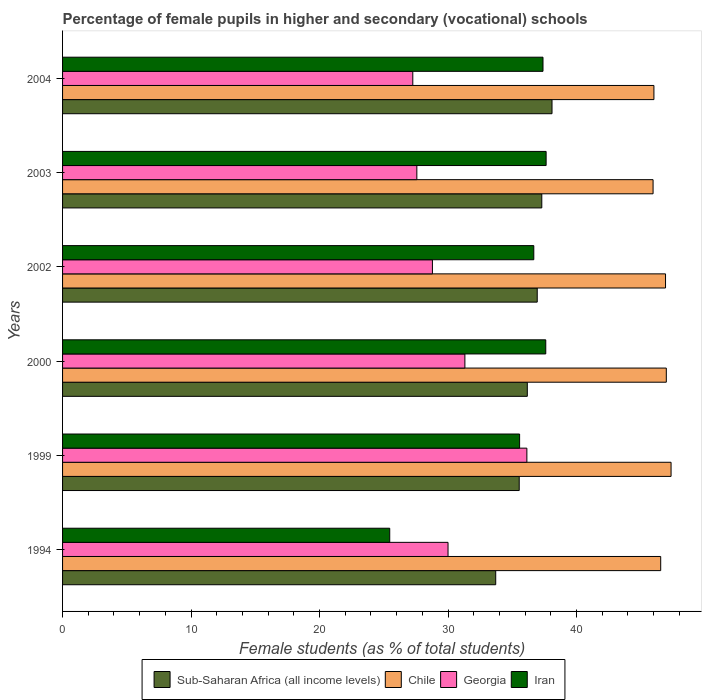How many different coloured bars are there?
Keep it short and to the point. 4. How many groups of bars are there?
Make the answer very short. 6. Are the number of bars on each tick of the Y-axis equal?
Your answer should be very brief. Yes. How many bars are there on the 4th tick from the bottom?
Your response must be concise. 4. What is the label of the 3rd group of bars from the top?
Keep it short and to the point. 2002. What is the percentage of female pupils in higher and secondary schools in Chile in 2000?
Ensure brevity in your answer.  46.99. Across all years, what is the maximum percentage of female pupils in higher and secondary schools in Iran?
Offer a terse response. 37.64. Across all years, what is the minimum percentage of female pupils in higher and secondary schools in Iran?
Keep it short and to the point. 25.46. In which year was the percentage of female pupils in higher and secondary schools in Sub-Saharan Africa (all income levels) maximum?
Give a very brief answer. 2004. In which year was the percentage of female pupils in higher and secondary schools in Iran minimum?
Ensure brevity in your answer.  1994. What is the total percentage of female pupils in higher and secondary schools in Georgia in the graph?
Your answer should be very brief. 181.07. What is the difference between the percentage of female pupils in higher and secondary schools in Georgia in 1999 and that in 2003?
Your answer should be very brief. 8.56. What is the difference between the percentage of female pupils in higher and secondary schools in Georgia in 2003 and the percentage of female pupils in higher and secondary schools in Chile in 2002?
Make the answer very short. -19.36. What is the average percentage of female pupils in higher and secondary schools in Chile per year?
Provide a short and direct response. 46.64. In the year 2004, what is the difference between the percentage of female pupils in higher and secondary schools in Georgia and percentage of female pupils in higher and secondary schools in Chile?
Your answer should be very brief. -18.77. In how many years, is the percentage of female pupils in higher and secondary schools in Georgia greater than 4 %?
Provide a short and direct response. 6. What is the ratio of the percentage of female pupils in higher and secondary schools in Iran in 2002 to that in 2004?
Offer a very short reply. 0.98. What is the difference between the highest and the second highest percentage of female pupils in higher and secondary schools in Sub-Saharan Africa (all income levels)?
Provide a short and direct response. 0.8. What is the difference between the highest and the lowest percentage of female pupils in higher and secondary schools in Sub-Saharan Africa (all income levels)?
Make the answer very short. 4.38. Is the sum of the percentage of female pupils in higher and secondary schools in Sub-Saharan Africa (all income levels) in 2002 and 2003 greater than the maximum percentage of female pupils in higher and secondary schools in Iran across all years?
Provide a short and direct response. Yes. What does the 4th bar from the bottom in 2003 represents?
Offer a very short reply. Iran. Is it the case that in every year, the sum of the percentage of female pupils in higher and secondary schools in Sub-Saharan Africa (all income levels) and percentage of female pupils in higher and secondary schools in Iran is greater than the percentage of female pupils in higher and secondary schools in Georgia?
Give a very brief answer. Yes. How are the legend labels stacked?
Give a very brief answer. Horizontal. What is the title of the graph?
Your answer should be compact. Percentage of female pupils in higher and secondary (vocational) schools. What is the label or title of the X-axis?
Keep it short and to the point. Female students (as % of total students). What is the label or title of the Y-axis?
Offer a very short reply. Years. What is the Female students (as % of total students) in Sub-Saharan Africa (all income levels) in 1994?
Provide a succinct answer. 33.71. What is the Female students (as % of total students) of Chile in 1994?
Ensure brevity in your answer.  46.55. What is the Female students (as % of total students) of Georgia in 1994?
Offer a terse response. 30. What is the Female students (as % of total students) in Iran in 1994?
Keep it short and to the point. 25.46. What is the Female students (as % of total students) in Sub-Saharan Africa (all income levels) in 1999?
Your answer should be compact. 35.54. What is the Female students (as % of total students) of Chile in 1999?
Your response must be concise. 47.36. What is the Female students (as % of total students) in Georgia in 1999?
Ensure brevity in your answer.  36.14. What is the Female students (as % of total students) of Iran in 1999?
Offer a very short reply. 35.57. What is the Female students (as % of total students) of Sub-Saharan Africa (all income levels) in 2000?
Your response must be concise. 36.17. What is the Female students (as % of total students) of Chile in 2000?
Your response must be concise. 46.99. What is the Female students (as % of total students) in Georgia in 2000?
Give a very brief answer. 31.31. What is the Female students (as % of total students) in Iran in 2000?
Ensure brevity in your answer.  37.61. What is the Female students (as % of total students) of Sub-Saharan Africa (all income levels) in 2002?
Your answer should be very brief. 36.94. What is the Female students (as % of total students) of Chile in 2002?
Keep it short and to the point. 46.93. What is the Female students (as % of total students) of Georgia in 2002?
Make the answer very short. 28.79. What is the Female students (as % of total students) in Iran in 2002?
Provide a short and direct response. 36.68. What is the Female students (as % of total students) of Sub-Saharan Africa (all income levels) in 2003?
Provide a short and direct response. 37.3. What is the Female students (as % of total students) in Chile in 2003?
Provide a short and direct response. 45.96. What is the Female students (as % of total students) in Georgia in 2003?
Provide a succinct answer. 27.57. What is the Female students (as % of total students) in Iran in 2003?
Provide a short and direct response. 37.64. What is the Female students (as % of total students) of Sub-Saharan Africa (all income levels) in 2004?
Provide a succinct answer. 38.1. What is the Female students (as % of total students) of Chile in 2004?
Your answer should be very brief. 46.03. What is the Female students (as % of total students) of Georgia in 2004?
Keep it short and to the point. 27.26. What is the Female students (as % of total students) of Iran in 2004?
Give a very brief answer. 37.39. Across all years, what is the maximum Female students (as % of total students) of Sub-Saharan Africa (all income levels)?
Provide a succinct answer. 38.1. Across all years, what is the maximum Female students (as % of total students) of Chile?
Your response must be concise. 47.36. Across all years, what is the maximum Female students (as % of total students) of Georgia?
Your answer should be compact. 36.14. Across all years, what is the maximum Female students (as % of total students) in Iran?
Make the answer very short. 37.64. Across all years, what is the minimum Female students (as % of total students) in Sub-Saharan Africa (all income levels)?
Ensure brevity in your answer.  33.71. Across all years, what is the minimum Female students (as % of total students) in Chile?
Provide a succinct answer. 45.96. Across all years, what is the minimum Female students (as % of total students) of Georgia?
Make the answer very short. 27.26. Across all years, what is the minimum Female students (as % of total students) of Iran?
Your response must be concise. 25.46. What is the total Female students (as % of total students) in Sub-Saharan Africa (all income levels) in the graph?
Provide a succinct answer. 217.77. What is the total Female students (as % of total students) in Chile in the graph?
Your answer should be compact. 279.82. What is the total Female students (as % of total students) in Georgia in the graph?
Your answer should be very brief. 181.07. What is the total Female students (as % of total students) of Iran in the graph?
Your answer should be very brief. 210.35. What is the difference between the Female students (as % of total students) of Sub-Saharan Africa (all income levels) in 1994 and that in 1999?
Keep it short and to the point. -1.83. What is the difference between the Female students (as % of total students) in Chile in 1994 and that in 1999?
Your response must be concise. -0.81. What is the difference between the Female students (as % of total students) in Georgia in 1994 and that in 1999?
Provide a short and direct response. -6.14. What is the difference between the Female students (as % of total students) of Iran in 1994 and that in 1999?
Ensure brevity in your answer.  -10.11. What is the difference between the Female students (as % of total students) of Sub-Saharan Africa (all income levels) in 1994 and that in 2000?
Your answer should be very brief. -2.46. What is the difference between the Female students (as % of total students) of Chile in 1994 and that in 2000?
Your answer should be very brief. -0.44. What is the difference between the Female students (as % of total students) of Georgia in 1994 and that in 2000?
Your response must be concise. -1.31. What is the difference between the Female students (as % of total students) in Iran in 1994 and that in 2000?
Offer a terse response. -12.15. What is the difference between the Female students (as % of total students) of Sub-Saharan Africa (all income levels) in 1994 and that in 2002?
Keep it short and to the point. -3.23. What is the difference between the Female students (as % of total students) of Chile in 1994 and that in 2002?
Provide a succinct answer. -0.38. What is the difference between the Female students (as % of total students) in Georgia in 1994 and that in 2002?
Provide a short and direct response. 1.22. What is the difference between the Female students (as % of total students) of Iran in 1994 and that in 2002?
Your answer should be compact. -11.21. What is the difference between the Female students (as % of total students) in Sub-Saharan Africa (all income levels) in 1994 and that in 2003?
Give a very brief answer. -3.59. What is the difference between the Female students (as % of total students) of Chile in 1994 and that in 2003?
Offer a terse response. 0.59. What is the difference between the Female students (as % of total students) of Georgia in 1994 and that in 2003?
Your answer should be compact. 2.43. What is the difference between the Female students (as % of total students) of Iran in 1994 and that in 2003?
Make the answer very short. -12.17. What is the difference between the Female students (as % of total students) of Sub-Saharan Africa (all income levels) in 1994 and that in 2004?
Make the answer very short. -4.38. What is the difference between the Female students (as % of total students) of Chile in 1994 and that in 2004?
Provide a succinct answer. 0.53. What is the difference between the Female students (as % of total students) of Georgia in 1994 and that in 2004?
Offer a terse response. 2.74. What is the difference between the Female students (as % of total students) of Iran in 1994 and that in 2004?
Offer a very short reply. -11.93. What is the difference between the Female students (as % of total students) of Sub-Saharan Africa (all income levels) in 1999 and that in 2000?
Offer a terse response. -0.63. What is the difference between the Female students (as % of total students) of Chile in 1999 and that in 2000?
Offer a terse response. 0.37. What is the difference between the Female students (as % of total students) in Georgia in 1999 and that in 2000?
Provide a short and direct response. 4.82. What is the difference between the Female students (as % of total students) of Iran in 1999 and that in 2000?
Offer a terse response. -2.04. What is the difference between the Female students (as % of total students) in Sub-Saharan Africa (all income levels) in 1999 and that in 2002?
Provide a short and direct response. -1.4. What is the difference between the Female students (as % of total students) in Chile in 1999 and that in 2002?
Give a very brief answer. 0.43. What is the difference between the Female students (as % of total students) of Georgia in 1999 and that in 2002?
Provide a short and direct response. 7.35. What is the difference between the Female students (as % of total students) of Iran in 1999 and that in 2002?
Give a very brief answer. -1.1. What is the difference between the Female students (as % of total students) in Sub-Saharan Africa (all income levels) in 1999 and that in 2003?
Make the answer very short. -1.76. What is the difference between the Female students (as % of total students) of Chile in 1999 and that in 2003?
Ensure brevity in your answer.  1.4. What is the difference between the Female students (as % of total students) in Georgia in 1999 and that in 2003?
Give a very brief answer. 8.56. What is the difference between the Female students (as % of total students) of Iran in 1999 and that in 2003?
Provide a succinct answer. -2.06. What is the difference between the Female students (as % of total students) of Sub-Saharan Africa (all income levels) in 1999 and that in 2004?
Make the answer very short. -2.55. What is the difference between the Female students (as % of total students) of Chile in 1999 and that in 2004?
Provide a short and direct response. 1.33. What is the difference between the Female students (as % of total students) of Georgia in 1999 and that in 2004?
Keep it short and to the point. 8.88. What is the difference between the Female students (as % of total students) in Iran in 1999 and that in 2004?
Offer a very short reply. -1.82. What is the difference between the Female students (as % of total students) in Sub-Saharan Africa (all income levels) in 2000 and that in 2002?
Ensure brevity in your answer.  -0.77. What is the difference between the Female students (as % of total students) of Chile in 2000 and that in 2002?
Your answer should be compact. 0.06. What is the difference between the Female students (as % of total students) of Georgia in 2000 and that in 2002?
Ensure brevity in your answer.  2.53. What is the difference between the Female students (as % of total students) of Iran in 2000 and that in 2002?
Keep it short and to the point. 0.93. What is the difference between the Female students (as % of total students) of Sub-Saharan Africa (all income levels) in 2000 and that in 2003?
Your answer should be compact. -1.13. What is the difference between the Female students (as % of total students) in Chile in 2000 and that in 2003?
Your response must be concise. 1.03. What is the difference between the Female students (as % of total students) in Georgia in 2000 and that in 2003?
Offer a terse response. 3.74. What is the difference between the Female students (as % of total students) of Iran in 2000 and that in 2003?
Your response must be concise. -0.03. What is the difference between the Female students (as % of total students) in Sub-Saharan Africa (all income levels) in 2000 and that in 2004?
Give a very brief answer. -1.92. What is the difference between the Female students (as % of total students) in Chile in 2000 and that in 2004?
Your answer should be compact. 0.96. What is the difference between the Female students (as % of total students) of Georgia in 2000 and that in 2004?
Give a very brief answer. 4.06. What is the difference between the Female students (as % of total students) of Iran in 2000 and that in 2004?
Your answer should be very brief. 0.22. What is the difference between the Female students (as % of total students) in Sub-Saharan Africa (all income levels) in 2002 and that in 2003?
Keep it short and to the point. -0.36. What is the difference between the Female students (as % of total students) in Chile in 2002 and that in 2003?
Ensure brevity in your answer.  0.97. What is the difference between the Female students (as % of total students) of Georgia in 2002 and that in 2003?
Offer a terse response. 1.21. What is the difference between the Female students (as % of total students) of Iran in 2002 and that in 2003?
Provide a succinct answer. -0.96. What is the difference between the Female students (as % of total students) in Sub-Saharan Africa (all income levels) in 2002 and that in 2004?
Offer a terse response. -1.15. What is the difference between the Female students (as % of total students) of Chile in 2002 and that in 2004?
Offer a terse response. 0.9. What is the difference between the Female students (as % of total students) of Georgia in 2002 and that in 2004?
Offer a very short reply. 1.53. What is the difference between the Female students (as % of total students) in Iran in 2002 and that in 2004?
Give a very brief answer. -0.72. What is the difference between the Female students (as % of total students) of Sub-Saharan Africa (all income levels) in 2003 and that in 2004?
Provide a short and direct response. -0.8. What is the difference between the Female students (as % of total students) of Chile in 2003 and that in 2004?
Offer a terse response. -0.07. What is the difference between the Female students (as % of total students) in Georgia in 2003 and that in 2004?
Ensure brevity in your answer.  0.32. What is the difference between the Female students (as % of total students) in Iran in 2003 and that in 2004?
Your response must be concise. 0.24. What is the difference between the Female students (as % of total students) of Sub-Saharan Africa (all income levels) in 1994 and the Female students (as % of total students) of Chile in 1999?
Your answer should be compact. -13.65. What is the difference between the Female students (as % of total students) in Sub-Saharan Africa (all income levels) in 1994 and the Female students (as % of total students) in Georgia in 1999?
Make the answer very short. -2.42. What is the difference between the Female students (as % of total students) of Sub-Saharan Africa (all income levels) in 1994 and the Female students (as % of total students) of Iran in 1999?
Your response must be concise. -1.86. What is the difference between the Female students (as % of total students) of Chile in 1994 and the Female students (as % of total students) of Georgia in 1999?
Provide a short and direct response. 10.42. What is the difference between the Female students (as % of total students) of Chile in 1994 and the Female students (as % of total students) of Iran in 1999?
Provide a short and direct response. 10.98. What is the difference between the Female students (as % of total students) in Georgia in 1994 and the Female students (as % of total students) in Iran in 1999?
Keep it short and to the point. -5.57. What is the difference between the Female students (as % of total students) in Sub-Saharan Africa (all income levels) in 1994 and the Female students (as % of total students) in Chile in 2000?
Provide a short and direct response. -13.28. What is the difference between the Female students (as % of total students) in Sub-Saharan Africa (all income levels) in 1994 and the Female students (as % of total students) in Georgia in 2000?
Your answer should be compact. 2.4. What is the difference between the Female students (as % of total students) in Sub-Saharan Africa (all income levels) in 1994 and the Female students (as % of total students) in Iran in 2000?
Your answer should be very brief. -3.9. What is the difference between the Female students (as % of total students) in Chile in 1994 and the Female students (as % of total students) in Georgia in 2000?
Your answer should be compact. 15.24. What is the difference between the Female students (as % of total students) in Chile in 1994 and the Female students (as % of total students) in Iran in 2000?
Give a very brief answer. 8.95. What is the difference between the Female students (as % of total students) in Georgia in 1994 and the Female students (as % of total students) in Iran in 2000?
Make the answer very short. -7.61. What is the difference between the Female students (as % of total students) in Sub-Saharan Africa (all income levels) in 1994 and the Female students (as % of total students) in Chile in 2002?
Provide a succinct answer. -13.22. What is the difference between the Female students (as % of total students) in Sub-Saharan Africa (all income levels) in 1994 and the Female students (as % of total students) in Georgia in 2002?
Your answer should be very brief. 4.93. What is the difference between the Female students (as % of total students) in Sub-Saharan Africa (all income levels) in 1994 and the Female students (as % of total students) in Iran in 2002?
Provide a succinct answer. -2.96. What is the difference between the Female students (as % of total students) of Chile in 1994 and the Female students (as % of total students) of Georgia in 2002?
Keep it short and to the point. 17.77. What is the difference between the Female students (as % of total students) in Chile in 1994 and the Female students (as % of total students) in Iran in 2002?
Your response must be concise. 9.88. What is the difference between the Female students (as % of total students) of Georgia in 1994 and the Female students (as % of total students) of Iran in 2002?
Give a very brief answer. -6.68. What is the difference between the Female students (as % of total students) in Sub-Saharan Africa (all income levels) in 1994 and the Female students (as % of total students) in Chile in 2003?
Make the answer very short. -12.25. What is the difference between the Female students (as % of total students) in Sub-Saharan Africa (all income levels) in 1994 and the Female students (as % of total students) in Georgia in 2003?
Provide a short and direct response. 6.14. What is the difference between the Female students (as % of total students) in Sub-Saharan Africa (all income levels) in 1994 and the Female students (as % of total students) in Iran in 2003?
Your response must be concise. -3.92. What is the difference between the Female students (as % of total students) of Chile in 1994 and the Female students (as % of total students) of Georgia in 2003?
Your answer should be very brief. 18.98. What is the difference between the Female students (as % of total students) in Chile in 1994 and the Female students (as % of total students) in Iran in 2003?
Ensure brevity in your answer.  8.92. What is the difference between the Female students (as % of total students) in Georgia in 1994 and the Female students (as % of total students) in Iran in 2003?
Your answer should be very brief. -7.63. What is the difference between the Female students (as % of total students) of Sub-Saharan Africa (all income levels) in 1994 and the Female students (as % of total students) of Chile in 2004?
Make the answer very short. -12.31. What is the difference between the Female students (as % of total students) of Sub-Saharan Africa (all income levels) in 1994 and the Female students (as % of total students) of Georgia in 2004?
Offer a very short reply. 6.45. What is the difference between the Female students (as % of total students) of Sub-Saharan Africa (all income levels) in 1994 and the Female students (as % of total students) of Iran in 2004?
Your answer should be compact. -3.68. What is the difference between the Female students (as % of total students) of Chile in 1994 and the Female students (as % of total students) of Georgia in 2004?
Provide a succinct answer. 19.3. What is the difference between the Female students (as % of total students) of Chile in 1994 and the Female students (as % of total students) of Iran in 2004?
Ensure brevity in your answer.  9.16. What is the difference between the Female students (as % of total students) in Georgia in 1994 and the Female students (as % of total students) in Iran in 2004?
Your answer should be very brief. -7.39. What is the difference between the Female students (as % of total students) in Sub-Saharan Africa (all income levels) in 1999 and the Female students (as % of total students) in Chile in 2000?
Your response must be concise. -11.45. What is the difference between the Female students (as % of total students) of Sub-Saharan Africa (all income levels) in 1999 and the Female students (as % of total students) of Georgia in 2000?
Ensure brevity in your answer.  4.23. What is the difference between the Female students (as % of total students) in Sub-Saharan Africa (all income levels) in 1999 and the Female students (as % of total students) in Iran in 2000?
Your answer should be compact. -2.07. What is the difference between the Female students (as % of total students) in Chile in 1999 and the Female students (as % of total students) in Georgia in 2000?
Offer a very short reply. 16.05. What is the difference between the Female students (as % of total students) in Chile in 1999 and the Female students (as % of total students) in Iran in 2000?
Your response must be concise. 9.75. What is the difference between the Female students (as % of total students) in Georgia in 1999 and the Female students (as % of total students) in Iran in 2000?
Offer a very short reply. -1.47. What is the difference between the Female students (as % of total students) of Sub-Saharan Africa (all income levels) in 1999 and the Female students (as % of total students) of Chile in 2002?
Your answer should be very brief. -11.39. What is the difference between the Female students (as % of total students) of Sub-Saharan Africa (all income levels) in 1999 and the Female students (as % of total students) of Georgia in 2002?
Your answer should be compact. 6.76. What is the difference between the Female students (as % of total students) in Sub-Saharan Africa (all income levels) in 1999 and the Female students (as % of total students) in Iran in 2002?
Give a very brief answer. -1.13. What is the difference between the Female students (as % of total students) of Chile in 1999 and the Female students (as % of total students) of Georgia in 2002?
Ensure brevity in your answer.  18.57. What is the difference between the Female students (as % of total students) of Chile in 1999 and the Female students (as % of total students) of Iran in 2002?
Offer a very short reply. 10.68. What is the difference between the Female students (as % of total students) of Georgia in 1999 and the Female students (as % of total students) of Iran in 2002?
Make the answer very short. -0.54. What is the difference between the Female students (as % of total students) in Sub-Saharan Africa (all income levels) in 1999 and the Female students (as % of total students) in Chile in 2003?
Offer a terse response. -10.42. What is the difference between the Female students (as % of total students) of Sub-Saharan Africa (all income levels) in 1999 and the Female students (as % of total students) of Georgia in 2003?
Keep it short and to the point. 7.97. What is the difference between the Female students (as % of total students) in Sub-Saharan Africa (all income levels) in 1999 and the Female students (as % of total students) in Iran in 2003?
Ensure brevity in your answer.  -2.09. What is the difference between the Female students (as % of total students) of Chile in 1999 and the Female students (as % of total students) of Georgia in 2003?
Make the answer very short. 19.79. What is the difference between the Female students (as % of total students) in Chile in 1999 and the Female students (as % of total students) in Iran in 2003?
Your response must be concise. 9.72. What is the difference between the Female students (as % of total students) in Georgia in 1999 and the Female students (as % of total students) in Iran in 2003?
Provide a succinct answer. -1.5. What is the difference between the Female students (as % of total students) of Sub-Saharan Africa (all income levels) in 1999 and the Female students (as % of total students) of Chile in 2004?
Give a very brief answer. -10.48. What is the difference between the Female students (as % of total students) of Sub-Saharan Africa (all income levels) in 1999 and the Female students (as % of total students) of Georgia in 2004?
Provide a short and direct response. 8.28. What is the difference between the Female students (as % of total students) in Sub-Saharan Africa (all income levels) in 1999 and the Female students (as % of total students) in Iran in 2004?
Make the answer very short. -1.85. What is the difference between the Female students (as % of total students) in Chile in 1999 and the Female students (as % of total students) in Georgia in 2004?
Your answer should be very brief. 20.1. What is the difference between the Female students (as % of total students) of Chile in 1999 and the Female students (as % of total students) of Iran in 2004?
Your response must be concise. 9.97. What is the difference between the Female students (as % of total students) of Georgia in 1999 and the Female students (as % of total students) of Iran in 2004?
Keep it short and to the point. -1.25. What is the difference between the Female students (as % of total students) in Sub-Saharan Africa (all income levels) in 2000 and the Female students (as % of total students) in Chile in 2002?
Give a very brief answer. -10.76. What is the difference between the Female students (as % of total students) of Sub-Saharan Africa (all income levels) in 2000 and the Female students (as % of total students) of Georgia in 2002?
Offer a very short reply. 7.39. What is the difference between the Female students (as % of total students) of Sub-Saharan Africa (all income levels) in 2000 and the Female students (as % of total students) of Iran in 2002?
Offer a very short reply. -0.51. What is the difference between the Female students (as % of total students) in Chile in 2000 and the Female students (as % of total students) in Georgia in 2002?
Keep it short and to the point. 18.2. What is the difference between the Female students (as % of total students) in Chile in 2000 and the Female students (as % of total students) in Iran in 2002?
Ensure brevity in your answer.  10.31. What is the difference between the Female students (as % of total students) of Georgia in 2000 and the Female students (as % of total students) of Iran in 2002?
Make the answer very short. -5.36. What is the difference between the Female students (as % of total students) of Sub-Saharan Africa (all income levels) in 2000 and the Female students (as % of total students) of Chile in 2003?
Your answer should be compact. -9.79. What is the difference between the Female students (as % of total students) of Sub-Saharan Africa (all income levels) in 2000 and the Female students (as % of total students) of Georgia in 2003?
Make the answer very short. 8.6. What is the difference between the Female students (as % of total students) of Sub-Saharan Africa (all income levels) in 2000 and the Female students (as % of total students) of Iran in 2003?
Offer a very short reply. -1.46. What is the difference between the Female students (as % of total students) of Chile in 2000 and the Female students (as % of total students) of Georgia in 2003?
Make the answer very short. 19.42. What is the difference between the Female students (as % of total students) in Chile in 2000 and the Female students (as % of total students) in Iran in 2003?
Ensure brevity in your answer.  9.35. What is the difference between the Female students (as % of total students) of Georgia in 2000 and the Female students (as % of total students) of Iran in 2003?
Keep it short and to the point. -6.32. What is the difference between the Female students (as % of total students) of Sub-Saharan Africa (all income levels) in 2000 and the Female students (as % of total students) of Chile in 2004?
Offer a terse response. -9.85. What is the difference between the Female students (as % of total students) in Sub-Saharan Africa (all income levels) in 2000 and the Female students (as % of total students) in Georgia in 2004?
Offer a very short reply. 8.91. What is the difference between the Female students (as % of total students) of Sub-Saharan Africa (all income levels) in 2000 and the Female students (as % of total students) of Iran in 2004?
Provide a succinct answer. -1.22. What is the difference between the Female students (as % of total students) in Chile in 2000 and the Female students (as % of total students) in Georgia in 2004?
Provide a short and direct response. 19.73. What is the difference between the Female students (as % of total students) in Chile in 2000 and the Female students (as % of total students) in Iran in 2004?
Give a very brief answer. 9.6. What is the difference between the Female students (as % of total students) in Georgia in 2000 and the Female students (as % of total students) in Iran in 2004?
Provide a short and direct response. -6.08. What is the difference between the Female students (as % of total students) in Sub-Saharan Africa (all income levels) in 2002 and the Female students (as % of total students) in Chile in 2003?
Keep it short and to the point. -9.02. What is the difference between the Female students (as % of total students) of Sub-Saharan Africa (all income levels) in 2002 and the Female students (as % of total students) of Georgia in 2003?
Provide a short and direct response. 9.37. What is the difference between the Female students (as % of total students) of Sub-Saharan Africa (all income levels) in 2002 and the Female students (as % of total students) of Iran in 2003?
Ensure brevity in your answer.  -0.69. What is the difference between the Female students (as % of total students) in Chile in 2002 and the Female students (as % of total students) in Georgia in 2003?
Your answer should be very brief. 19.36. What is the difference between the Female students (as % of total students) in Chile in 2002 and the Female students (as % of total students) in Iran in 2003?
Ensure brevity in your answer.  9.29. What is the difference between the Female students (as % of total students) of Georgia in 2002 and the Female students (as % of total students) of Iran in 2003?
Your answer should be compact. -8.85. What is the difference between the Female students (as % of total students) of Sub-Saharan Africa (all income levels) in 2002 and the Female students (as % of total students) of Chile in 2004?
Provide a short and direct response. -9.08. What is the difference between the Female students (as % of total students) in Sub-Saharan Africa (all income levels) in 2002 and the Female students (as % of total students) in Georgia in 2004?
Keep it short and to the point. 9.69. What is the difference between the Female students (as % of total students) in Sub-Saharan Africa (all income levels) in 2002 and the Female students (as % of total students) in Iran in 2004?
Provide a short and direct response. -0.45. What is the difference between the Female students (as % of total students) in Chile in 2002 and the Female students (as % of total students) in Georgia in 2004?
Offer a terse response. 19.67. What is the difference between the Female students (as % of total students) in Chile in 2002 and the Female students (as % of total students) in Iran in 2004?
Ensure brevity in your answer.  9.54. What is the difference between the Female students (as % of total students) of Georgia in 2002 and the Female students (as % of total students) of Iran in 2004?
Provide a succinct answer. -8.61. What is the difference between the Female students (as % of total students) in Sub-Saharan Africa (all income levels) in 2003 and the Female students (as % of total students) in Chile in 2004?
Your answer should be very brief. -8.73. What is the difference between the Female students (as % of total students) in Sub-Saharan Africa (all income levels) in 2003 and the Female students (as % of total students) in Georgia in 2004?
Ensure brevity in your answer.  10.04. What is the difference between the Female students (as % of total students) of Sub-Saharan Africa (all income levels) in 2003 and the Female students (as % of total students) of Iran in 2004?
Keep it short and to the point. -0.09. What is the difference between the Female students (as % of total students) in Chile in 2003 and the Female students (as % of total students) in Georgia in 2004?
Offer a terse response. 18.7. What is the difference between the Female students (as % of total students) of Chile in 2003 and the Female students (as % of total students) of Iran in 2004?
Provide a succinct answer. 8.57. What is the difference between the Female students (as % of total students) in Georgia in 2003 and the Female students (as % of total students) in Iran in 2004?
Ensure brevity in your answer.  -9.82. What is the average Female students (as % of total students) in Sub-Saharan Africa (all income levels) per year?
Provide a short and direct response. 36.29. What is the average Female students (as % of total students) in Chile per year?
Offer a terse response. 46.64. What is the average Female students (as % of total students) in Georgia per year?
Ensure brevity in your answer.  30.18. What is the average Female students (as % of total students) in Iran per year?
Ensure brevity in your answer.  35.06. In the year 1994, what is the difference between the Female students (as % of total students) of Sub-Saharan Africa (all income levels) and Female students (as % of total students) of Chile?
Your answer should be very brief. -12.84. In the year 1994, what is the difference between the Female students (as % of total students) in Sub-Saharan Africa (all income levels) and Female students (as % of total students) in Georgia?
Your answer should be compact. 3.71. In the year 1994, what is the difference between the Female students (as % of total students) of Sub-Saharan Africa (all income levels) and Female students (as % of total students) of Iran?
Give a very brief answer. 8.25. In the year 1994, what is the difference between the Female students (as % of total students) in Chile and Female students (as % of total students) in Georgia?
Your answer should be very brief. 16.55. In the year 1994, what is the difference between the Female students (as % of total students) in Chile and Female students (as % of total students) in Iran?
Offer a terse response. 21.09. In the year 1994, what is the difference between the Female students (as % of total students) in Georgia and Female students (as % of total students) in Iran?
Provide a short and direct response. 4.54. In the year 1999, what is the difference between the Female students (as % of total students) of Sub-Saharan Africa (all income levels) and Female students (as % of total students) of Chile?
Provide a succinct answer. -11.82. In the year 1999, what is the difference between the Female students (as % of total students) in Sub-Saharan Africa (all income levels) and Female students (as % of total students) in Georgia?
Ensure brevity in your answer.  -0.6. In the year 1999, what is the difference between the Female students (as % of total students) of Sub-Saharan Africa (all income levels) and Female students (as % of total students) of Iran?
Make the answer very short. -0.03. In the year 1999, what is the difference between the Female students (as % of total students) in Chile and Female students (as % of total students) in Georgia?
Offer a very short reply. 11.22. In the year 1999, what is the difference between the Female students (as % of total students) in Chile and Female students (as % of total students) in Iran?
Provide a short and direct response. 11.79. In the year 1999, what is the difference between the Female students (as % of total students) in Georgia and Female students (as % of total students) in Iran?
Keep it short and to the point. 0.57. In the year 2000, what is the difference between the Female students (as % of total students) in Sub-Saharan Africa (all income levels) and Female students (as % of total students) in Chile?
Make the answer very short. -10.82. In the year 2000, what is the difference between the Female students (as % of total students) in Sub-Saharan Africa (all income levels) and Female students (as % of total students) in Georgia?
Provide a succinct answer. 4.86. In the year 2000, what is the difference between the Female students (as % of total students) in Sub-Saharan Africa (all income levels) and Female students (as % of total students) in Iran?
Provide a short and direct response. -1.44. In the year 2000, what is the difference between the Female students (as % of total students) in Chile and Female students (as % of total students) in Georgia?
Your answer should be very brief. 15.68. In the year 2000, what is the difference between the Female students (as % of total students) in Chile and Female students (as % of total students) in Iran?
Your answer should be compact. 9.38. In the year 2000, what is the difference between the Female students (as % of total students) of Georgia and Female students (as % of total students) of Iran?
Give a very brief answer. -6.29. In the year 2002, what is the difference between the Female students (as % of total students) of Sub-Saharan Africa (all income levels) and Female students (as % of total students) of Chile?
Your answer should be very brief. -9.99. In the year 2002, what is the difference between the Female students (as % of total students) of Sub-Saharan Africa (all income levels) and Female students (as % of total students) of Georgia?
Keep it short and to the point. 8.16. In the year 2002, what is the difference between the Female students (as % of total students) in Sub-Saharan Africa (all income levels) and Female students (as % of total students) in Iran?
Ensure brevity in your answer.  0.27. In the year 2002, what is the difference between the Female students (as % of total students) of Chile and Female students (as % of total students) of Georgia?
Make the answer very short. 18.14. In the year 2002, what is the difference between the Female students (as % of total students) in Chile and Female students (as % of total students) in Iran?
Offer a terse response. 10.25. In the year 2002, what is the difference between the Female students (as % of total students) of Georgia and Female students (as % of total students) of Iran?
Your response must be concise. -7.89. In the year 2003, what is the difference between the Female students (as % of total students) of Sub-Saharan Africa (all income levels) and Female students (as % of total students) of Chile?
Ensure brevity in your answer.  -8.66. In the year 2003, what is the difference between the Female students (as % of total students) in Sub-Saharan Africa (all income levels) and Female students (as % of total students) in Georgia?
Offer a very short reply. 9.73. In the year 2003, what is the difference between the Female students (as % of total students) in Sub-Saharan Africa (all income levels) and Female students (as % of total students) in Iran?
Give a very brief answer. -0.34. In the year 2003, what is the difference between the Female students (as % of total students) in Chile and Female students (as % of total students) in Georgia?
Give a very brief answer. 18.39. In the year 2003, what is the difference between the Female students (as % of total students) of Chile and Female students (as % of total students) of Iran?
Your answer should be compact. 8.32. In the year 2003, what is the difference between the Female students (as % of total students) of Georgia and Female students (as % of total students) of Iran?
Your response must be concise. -10.06. In the year 2004, what is the difference between the Female students (as % of total students) of Sub-Saharan Africa (all income levels) and Female students (as % of total students) of Chile?
Ensure brevity in your answer.  -7.93. In the year 2004, what is the difference between the Female students (as % of total students) in Sub-Saharan Africa (all income levels) and Female students (as % of total students) in Georgia?
Ensure brevity in your answer.  10.84. In the year 2004, what is the difference between the Female students (as % of total students) in Sub-Saharan Africa (all income levels) and Female students (as % of total students) in Iran?
Give a very brief answer. 0.7. In the year 2004, what is the difference between the Female students (as % of total students) in Chile and Female students (as % of total students) in Georgia?
Your answer should be very brief. 18.77. In the year 2004, what is the difference between the Female students (as % of total students) in Chile and Female students (as % of total students) in Iran?
Give a very brief answer. 8.63. In the year 2004, what is the difference between the Female students (as % of total students) of Georgia and Female students (as % of total students) of Iran?
Ensure brevity in your answer.  -10.13. What is the ratio of the Female students (as % of total students) of Sub-Saharan Africa (all income levels) in 1994 to that in 1999?
Your response must be concise. 0.95. What is the ratio of the Female students (as % of total students) in Georgia in 1994 to that in 1999?
Make the answer very short. 0.83. What is the ratio of the Female students (as % of total students) in Iran in 1994 to that in 1999?
Make the answer very short. 0.72. What is the ratio of the Female students (as % of total students) in Sub-Saharan Africa (all income levels) in 1994 to that in 2000?
Offer a very short reply. 0.93. What is the ratio of the Female students (as % of total students) of Georgia in 1994 to that in 2000?
Offer a terse response. 0.96. What is the ratio of the Female students (as % of total students) in Iran in 1994 to that in 2000?
Provide a succinct answer. 0.68. What is the ratio of the Female students (as % of total students) in Sub-Saharan Africa (all income levels) in 1994 to that in 2002?
Offer a very short reply. 0.91. What is the ratio of the Female students (as % of total students) of Georgia in 1994 to that in 2002?
Offer a very short reply. 1.04. What is the ratio of the Female students (as % of total students) in Iran in 1994 to that in 2002?
Provide a succinct answer. 0.69. What is the ratio of the Female students (as % of total students) in Sub-Saharan Africa (all income levels) in 1994 to that in 2003?
Offer a very short reply. 0.9. What is the ratio of the Female students (as % of total students) of Chile in 1994 to that in 2003?
Give a very brief answer. 1.01. What is the ratio of the Female students (as % of total students) in Georgia in 1994 to that in 2003?
Keep it short and to the point. 1.09. What is the ratio of the Female students (as % of total students) of Iran in 1994 to that in 2003?
Provide a succinct answer. 0.68. What is the ratio of the Female students (as % of total students) of Sub-Saharan Africa (all income levels) in 1994 to that in 2004?
Make the answer very short. 0.89. What is the ratio of the Female students (as % of total students) in Chile in 1994 to that in 2004?
Provide a succinct answer. 1.01. What is the ratio of the Female students (as % of total students) in Georgia in 1994 to that in 2004?
Offer a very short reply. 1.1. What is the ratio of the Female students (as % of total students) in Iran in 1994 to that in 2004?
Make the answer very short. 0.68. What is the ratio of the Female students (as % of total students) of Sub-Saharan Africa (all income levels) in 1999 to that in 2000?
Your answer should be very brief. 0.98. What is the ratio of the Female students (as % of total students) in Chile in 1999 to that in 2000?
Offer a terse response. 1.01. What is the ratio of the Female students (as % of total students) of Georgia in 1999 to that in 2000?
Your response must be concise. 1.15. What is the ratio of the Female students (as % of total students) of Iran in 1999 to that in 2000?
Your response must be concise. 0.95. What is the ratio of the Female students (as % of total students) in Sub-Saharan Africa (all income levels) in 1999 to that in 2002?
Your answer should be very brief. 0.96. What is the ratio of the Female students (as % of total students) in Chile in 1999 to that in 2002?
Make the answer very short. 1.01. What is the ratio of the Female students (as % of total students) in Georgia in 1999 to that in 2002?
Provide a short and direct response. 1.26. What is the ratio of the Female students (as % of total students) in Iran in 1999 to that in 2002?
Provide a succinct answer. 0.97. What is the ratio of the Female students (as % of total students) of Sub-Saharan Africa (all income levels) in 1999 to that in 2003?
Provide a succinct answer. 0.95. What is the ratio of the Female students (as % of total students) of Chile in 1999 to that in 2003?
Provide a short and direct response. 1.03. What is the ratio of the Female students (as % of total students) of Georgia in 1999 to that in 2003?
Make the answer very short. 1.31. What is the ratio of the Female students (as % of total students) in Iran in 1999 to that in 2003?
Your response must be concise. 0.95. What is the ratio of the Female students (as % of total students) in Sub-Saharan Africa (all income levels) in 1999 to that in 2004?
Your response must be concise. 0.93. What is the ratio of the Female students (as % of total students) of Chile in 1999 to that in 2004?
Make the answer very short. 1.03. What is the ratio of the Female students (as % of total students) of Georgia in 1999 to that in 2004?
Offer a very short reply. 1.33. What is the ratio of the Female students (as % of total students) of Iran in 1999 to that in 2004?
Provide a short and direct response. 0.95. What is the ratio of the Female students (as % of total students) of Sub-Saharan Africa (all income levels) in 2000 to that in 2002?
Keep it short and to the point. 0.98. What is the ratio of the Female students (as % of total students) in Chile in 2000 to that in 2002?
Give a very brief answer. 1. What is the ratio of the Female students (as % of total students) of Georgia in 2000 to that in 2002?
Your answer should be very brief. 1.09. What is the ratio of the Female students (as % of total students) of Iran in 2000 to that in 2002?
Give a very brief answer. 1.03. What is the ratio of the Female students (as % of total students) in Sub-Saharan Africa (all income levels) in 2000 to that in 2003?
Provide a short and direct response. 0.97. What is the ratio of the Female students (as % of total students) in Chile in 2000 to that in 2003?
Make the answer very short. 1.02. What is the ratio of the Female students (as % of total students) of Georgia in 2000 to that in 2003?
Provide a short and direct response. 1.14. What is the ratio of the Female students (as % of total students) of Sub-Saharan Africa (all income levels) in 2000 to that in 2004?
Offer a terse response. 0.95. What is the ratio of the Female students (as % of total students) of Chile in 2000 to that in 2004?
Ensure brevity in your answer.  1.02. What is the ratio of the Female students (as % of total students) in Georgia in 2000 to that in 2004?
Provide a short and direct response. 1.15. What is the ratio of the Female students (as % of total students) of Chile in 2002 to that in 2003?
Ensure brevity in your answer.  1.02. What is the ratio of the Female students (as % of total students) of Georgia in 2002 to that in 2003?
Your answer should be very brief. 1.04. What is the ratio of the Female students (as % of total students) of Iran in 2002 to that in 2003?
Provide a succinct answer. 0.97. What is the ratio of the Female students (as % of total students) of Sub-Saharan Africa (all income levels) in 2002 to that in 2004?
Keep it short and to the point. 0.97. What is the ratio of the Female students (as % of total students) in Chile in 2002 to that in 2004?
Your answer should be compact. 1.02. What is the ratio of the Female students (as % of total students) in Georgia in 2002 to that in 2004?
Offer a terse response. 1.06. What is the ratio of the Female students (as % of total students) of Iran in 2002 to that in 2004?
Offer a very short reply. 0.98. What is the ratio of the Female students (as % of total students) in Sub-Saharan Africa (all income levels) in 2003 to that in 2004?
Provide a succinct answer. 0.98. What is the ratio of the Female students (as % of total students) in Georgia in 2003 to that in 2004?
Offer a terse response. 1.01. What is the ratio of the Female students (as % of total students) of Iran in 2003 to that in 2004?
Make the answer very short. 1.01. What is the difference between the highest and the second highest Female students (as % of total students) of Sub-Saharan Africa (all income levels)?
Give a very brief answer. 0.8. What is the difference between the highest and the second highest Female students (as % of total students) in Chile?
Ensure brevity in your answer.  0.37. What is the difference between the highest and the second highest Female students (as % of total students) in Georgia?
Your answer should be very brief. 4.82. What is the difference between the highest and the second highest Female students (as % of total students) in Iran?
Your answer should be very brief. 0.03. What is the difference between the highest and the lowest Female students (as % of total students) in Sub-Saharan Africa (all income levels)?
Make the answer very short. 4.38. What is the difference between the highest and the lowest Female students (as % of total students) of Chile?
Keep it short and to the point. 1.4. What is the difference between the highest and the lowest Female students (as % of total students) of Georgia?
Keep it short and to the point. 8.88. What is the difference between the highest and the lowest Female students (as % of total students) in Iran?
Keep it short and to the point. 12.17. 